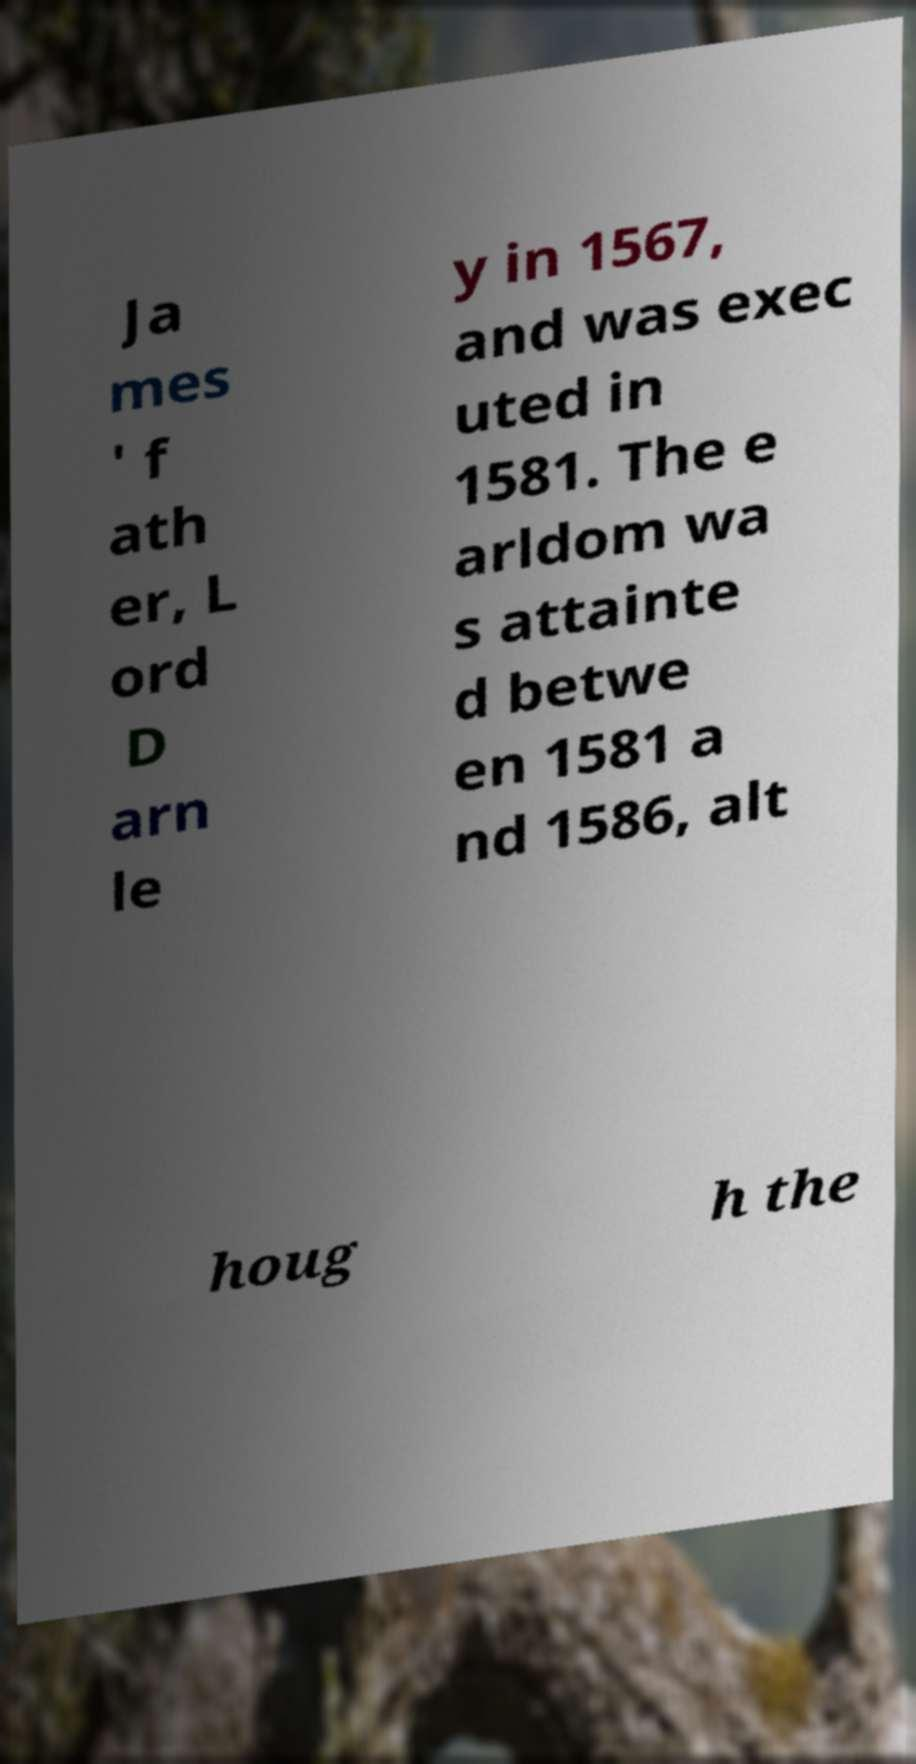Please identify and transcribe the text found in this image. Ja mes ' f ath er, L ord D arn le y in 1567, and was exec uted in 1581. The e arldom wa s attainte d betwe en 1581 a nd 1586, alt houg h the 